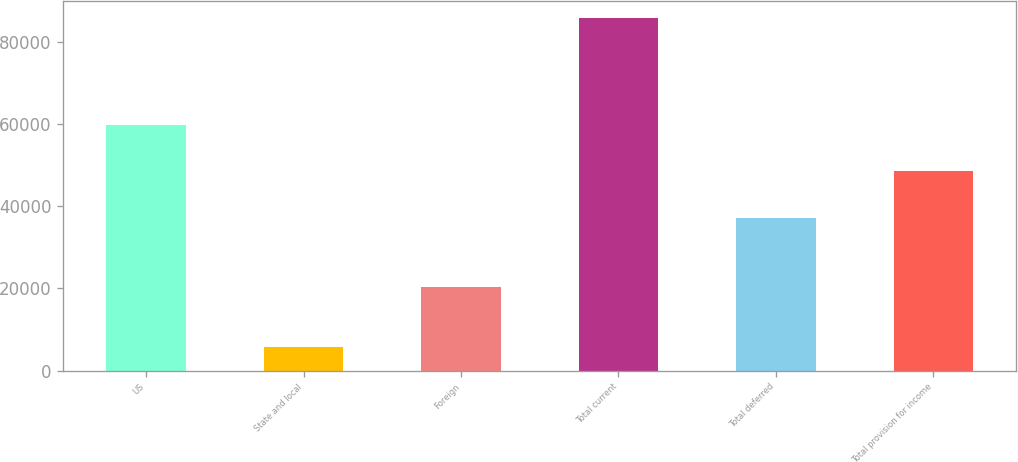<chart> <loc_0><loc_0><loc_500><loc_500><bar_chart><fcel>US<fcel>State and local<fcel>Foreign<fcel>Total current<fcel>Total deferred<fcel>Total provision for income<nl><fcel>59811<fcel>5764<fcel>20228<fcel>85803<fcel>37229<fcel>48574<nl></chart> 